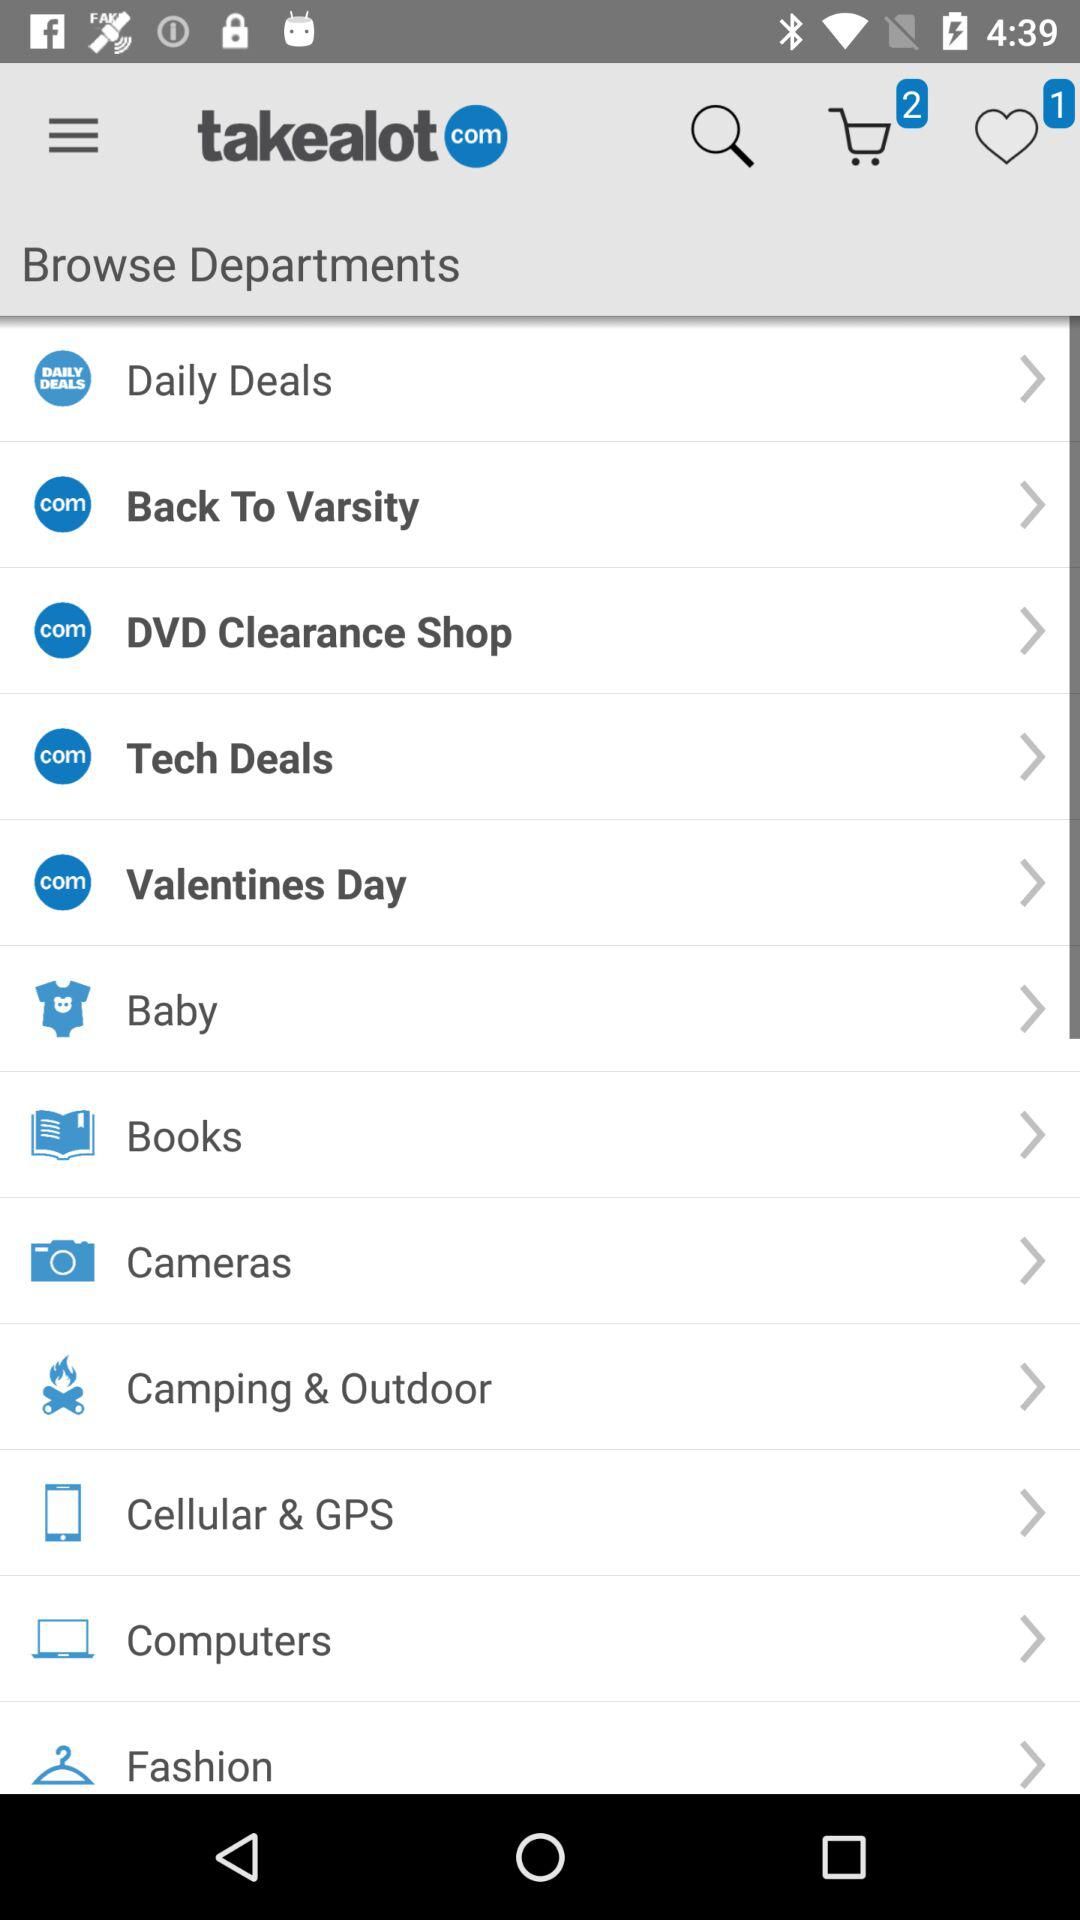What is the application name? The application name is "takealot". 